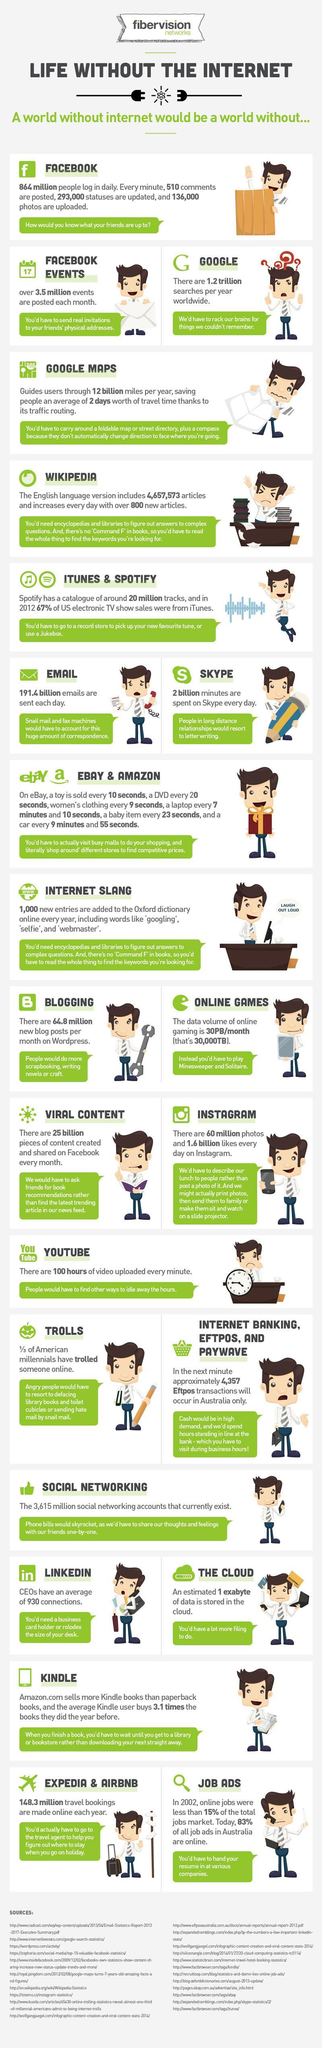What percentage of current job advertisements in Australia are not online?
Answer the question with a short phrase. 17 How many photo uploads are happening on Facebook in a month? 3.5 million How many articles are added to Wikipedia every 24 hours? 800 